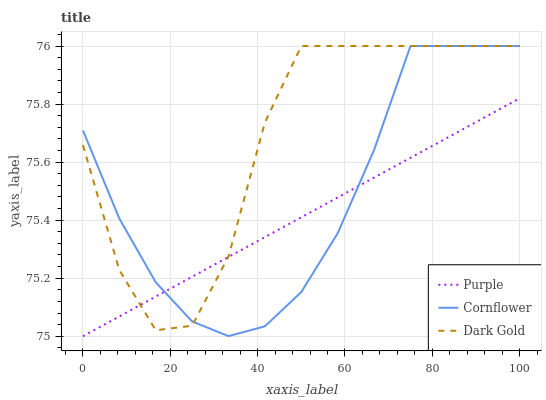Does Purple have the minimum area under the curve?
Answer yes or no. Yes. Does Dark Gold have the maximum area under the curve?
Answer yes or no. Yes. Does Cornflower have the minimum area under the curve?
Answer yes or no. No. Does Cornflower have the maximum area under the curve?
Answer yes or no. No. Is Purple the smoothest?
Answer yes or no. Yes. Is Dark Gold the roughest?
Answer yes or no. Yes. Is Cornflower the smoothest?
Answer yes or no. No. Is Cornflower the roughest?
Answer yes or no. No. Does Purple have the lowest value?
Answer yes or no. Yes. Does Cornflower have the lowest value?
Answer yes or no. No. Does Dark Gold have the highest value?
Answer yes or no. Yes. Does Cornflower intersect Purple?
Answer yes or no. Yes. Is Cornflower less than Purple?
Answer yes or no. No. Is Cornflower greater than Purple?
Answer yes or no. No. 